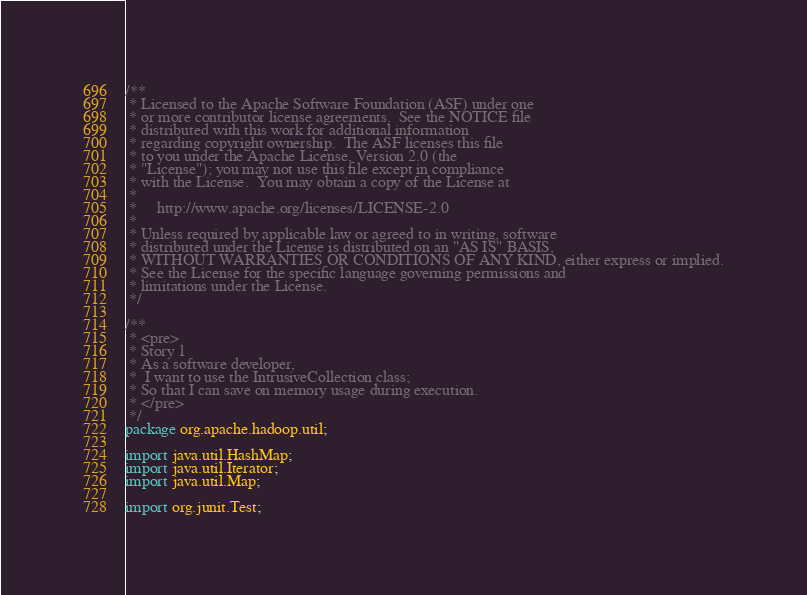<code> <loc_0><loc_0><loc_500><loc_500><_Java_>/**
 * Licensed to the Apache Software Foundation (ASF) under one
 * or more contributor license agreements.  See the NOTICE file
 * distributed with this work for additional information
 * regarding copyright ownership.  The ASF licenses this file
 * to you under the Apache License, Version 2.0 (the
 * "License"); you may not use this file except in compliance
 * with the License.  You may obtain a copy of the License at
 *
 *     http://www.apache.org/licenses/LICENSE-2.0
 *
 * Unless required by applicable law or agreed to in writing, software
 * distributed under the License is distributed on an "AS IS" BASIS,
 * WITHOUT WARRANTIES OR CONDITIONS OF ANY KIND, either express or implied.
 * See the License for the specific language governing permissions and
 * limitations under the License.
 */

/**
 * <pre>
 * Story 1
 * As a software developer,
 *  I want to use the IntrusiveCollection class;
 * So that I can save on memory usage during execution.
 * </pre>
 */
package org.apache.hadoop.util;

import java.util.HashMap;
import java.util.Iterator;
import java.util.Map;

import org.junit.Test;
</code> 